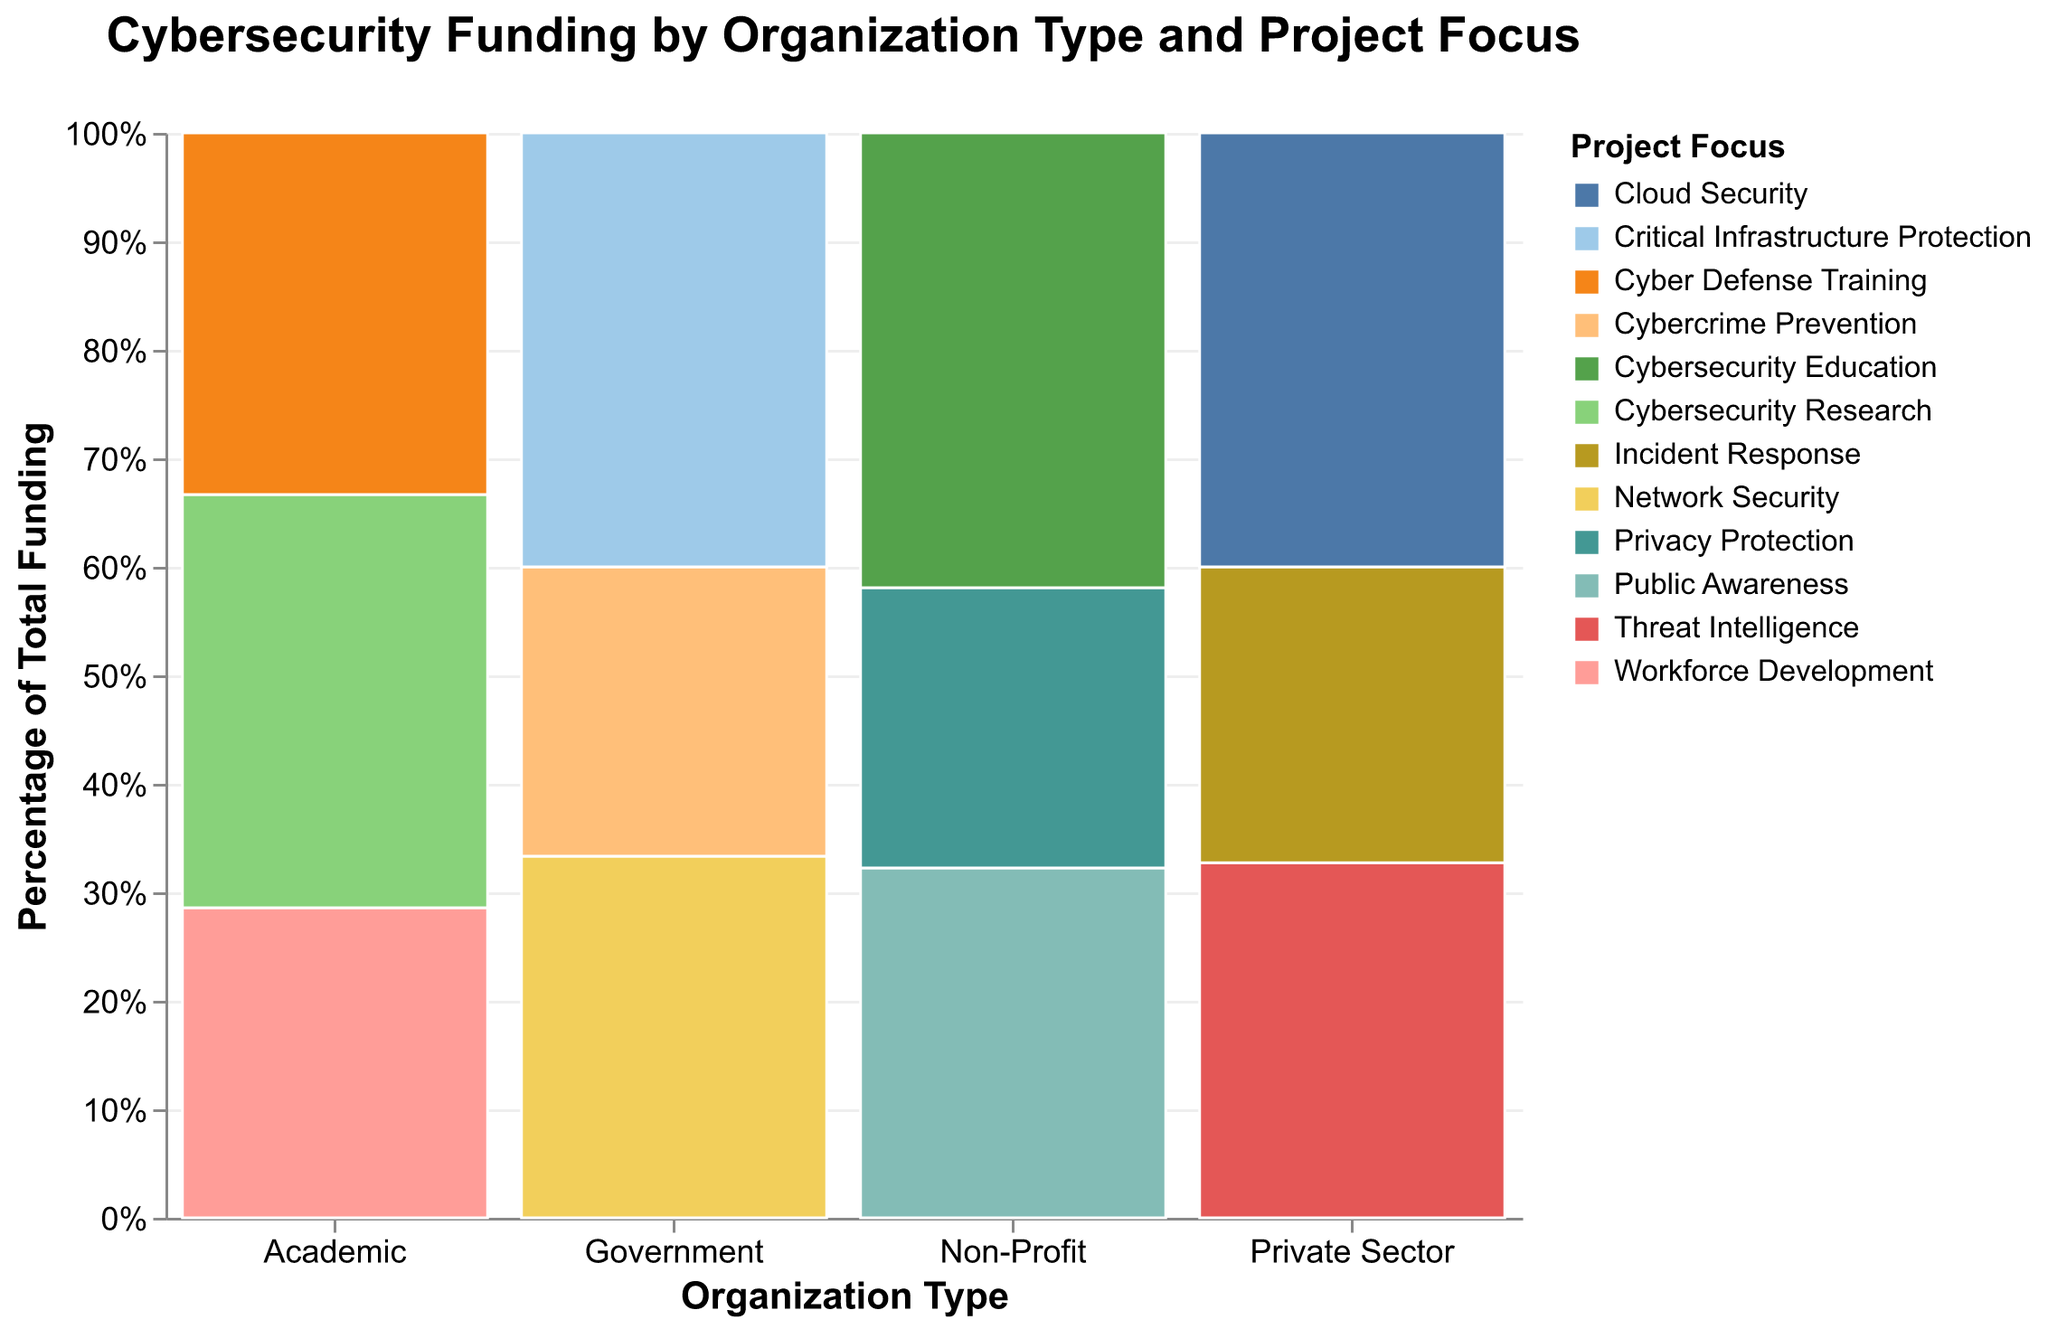What's the title of the figure? The title is displayed at the top of the figure and summarizes its content. In this case, you can directly read it from the top of the figure.
Answer: Cybersecurity Funding by Organization Type and Project Focus Which organization type receives the most funding? To determine this, look at the total height of the bars for each organization type. The tallest bar represents the organization type with the most funding.
Answer: Government What percentage of total funding is dedicated to Critical Infrastructure Protection by the Government? First, locate the Government section and then find the segment for Critical Infrastructure Protection in that section. Read its relative height within the Government bar and the y-axis provides percentages.
Answer: 15% How does the funding for Network Security by the Government compare to Threat Intelligence by the Private Sector? Compare the sections labeled Network Security under Government and Threat Intelligence under Private Sector. Identify which bar segment is taller.
Answer: Network Security receives more funding Which project focus has the least funding within the Non-Profit organization type? Identify the colored segments within the Non-Profit section and compare their heights. The smallest segment represents the least funding.
Answer: Privacy Protection What fraction of total funding is allocated to Cloud Security by the Private Sector? Find the Cloud Security segment in the Private Sector bar and refer to its height compared to the total y-axis.
Answer: 7.5% Is Cyber Defense Training funded more by Academic or by Non-Profit organizations? Locate the Cyber Defense Training segment in both Academic and Non-Profit sections and compare their heights.
Answer: Academic Compare the percentage of funding for Public Awareness by Non-Profit to Cybersecurity Research by Academic. Which is greater? Identify the segments for Public Awareness in Non-Profit and Cybersecurity Research in Academic, then compare their heights relative to their sections.
Answer: Cybersecurity Research Which organization type invests the most in Workforce Development projects? Locate the Workforce Development segments in all organizational types and see which one is the tallest.
Answer: Academic How many different project focuses are there across all organization types? Count the distinct number of colored segments across all bars which denote different project focuses.
Answer: 9 